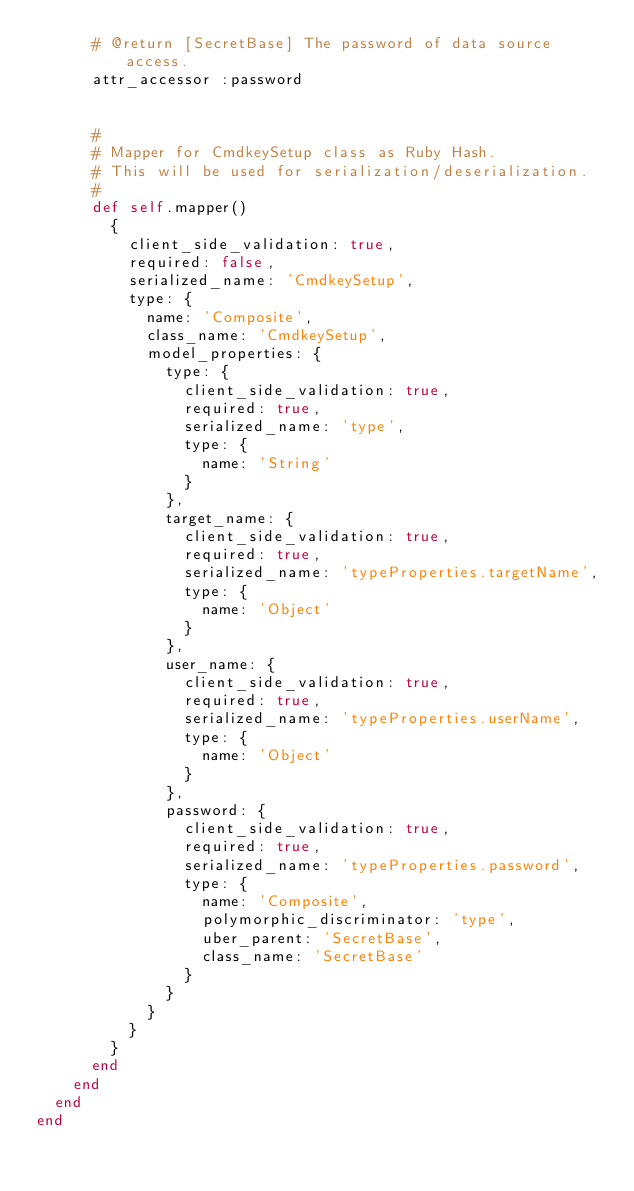<code> <loc_0><loc_0><loc_500><loc_500><_Ruby_>      # @return [SecretBase] The password of data source access.
      attr_accessor :password


      #
      # Mapper for CmdkeySetup class as Ruby Hash.
      # This will be used for serialization/deserialization.
      #
      def self.mapper()
        {
          client_side_validation: true,
          required: false,
          serialized_name: 'CmdkeySetup',
          type: {
            name: 'Composite',
            class_name: 'CmdkeySetup',
            model_properties: {
              type: {
                client_side_validation: true,
                required: true,
                serialized_name: 'type',
                type: {
                  name: 'String'
                }
              },
              target_name: {
                client_side_validation: true,
                required: true,
                serialized_name: 'typeProperties.targetName',
                type: {
                  name: 'Object'
                }
              },
              user_name: {
                client_side_validation: true,
                required: true,
                serialized_name: 'typeProperties.userName',
                type: {
                  name: 'Object'
                }
              },
              password: {
                client_side_validation: true,
                required: true,
                serialized_name: 'typeProperties.password',
                type: {
                  name: 'Composite',
                  polymorphic_discriminator: 'type',
                  uber_parent: 'SecretBase',
                  class_name: 'SecretBase'
                }
              }
            }
          }
        }
      end
    end
  end
end
</code> 